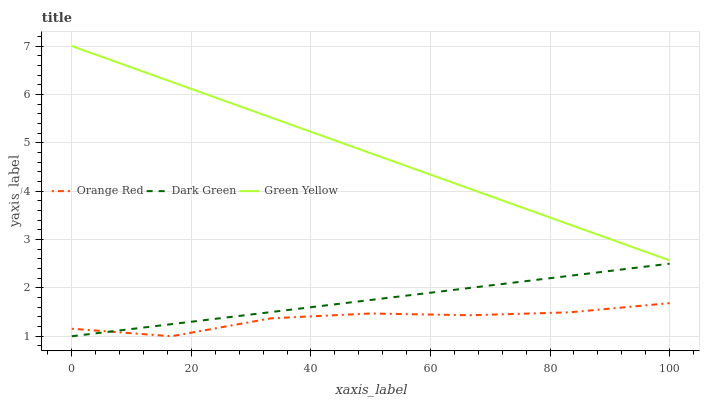Does Orange Red have the minimum area under the curve?
Answer yes or no. Yes. Does Green Yellow have the maximum area under the curve?
Answer yes or no. Yes. Does Dark Green have the minimum area under the curve?
Answer yes or no. No. Does Dark Green have the maximum area under the curve?
Answer yes or no. No. Is Dark Green the smoothest?
Answer yes or no. Yes. Is Orange Red the roughest?
Answer yes or no. Yes. Is Orange Red the smoothest?
Answer yes or no. No. Is Dark Green the roughest?
Answer yes or no. No. Does Orange Red have the lowest value?
Answer yes or no. Yes. Does Green Yellow have the highest value?
Answer yes or no. Yes. Does Dark Green have the highest value?
Answer yes or no. No. Is Orange Red less than Green Yellow?
Answer yes or no. Yes. Is Green Yellow greater than Orange Red?
Answer yes or no. Yes. Does Dark Green intersect Orange Red?
Answer yes or no. Yes. Is Dark Green less than Orange Red?
Answer yes or no. No. Is Dark Green greater than Orange Red?
Answer yes or no. No. Does Orange Red intersect Green Yellow?
Answer yes or no. No. 